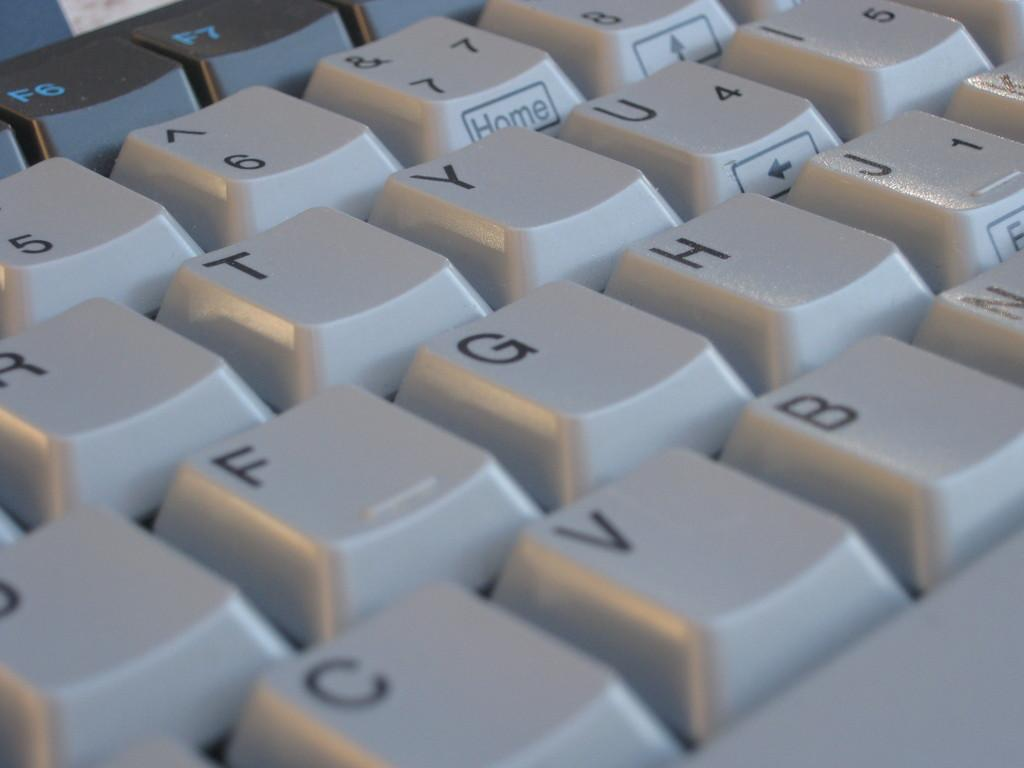What is the main object in the image? There is a keyboard in the image. What can be found on the keys of the keyboard? The keys have text on them. What is the color of some keys on the keyboard? Some keys are in white color. What is the color of the keys in the left top corner of the keyboard? The left top keys are in black color. How does the keyboard help in combing hair in the image? The keyboard does not help in combing hair in the image; it is an electronic device used for typing. 